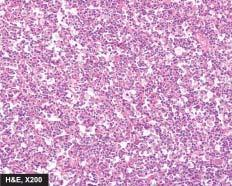what shows uniform cells having high mitotic rate?
Answer the question using a single word or phrase. The tumour 